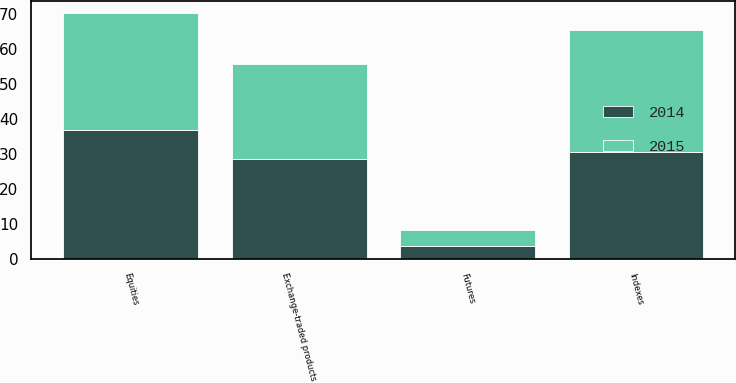Convert chart. <chart><loc_0><loc_0><loc_500><loc_500><stacked_bar_chart><ecel><fcel>Equities<fcel>Indexes<fcel>Exchange-traded products<fcel>Futures<nl><fcel>2015<fcel>33.5<fcel>34.8<fcel>27.3<fcel>4.4<nl><fcel>2014<fcel>36.9<fcel>30.7<fcel>28.6<fcel>3.8<nl></chart> 